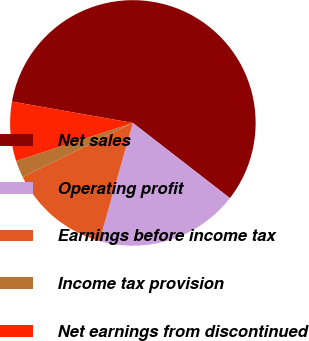Convert chart to OTSL. <chart><loc_0><loc_0><loc_500><loc_500><pie_chart><fcel>Net sales<fcel>Operating profit<fcel>Earnings before income tax<fcel>Income tax provision<fcel>Net earnings from discontinued<nl><fcel>57.71%<fcel>18.89%<fcel>13.35%<fcel>2.25%<fcel>7.8%<nl></chart> 